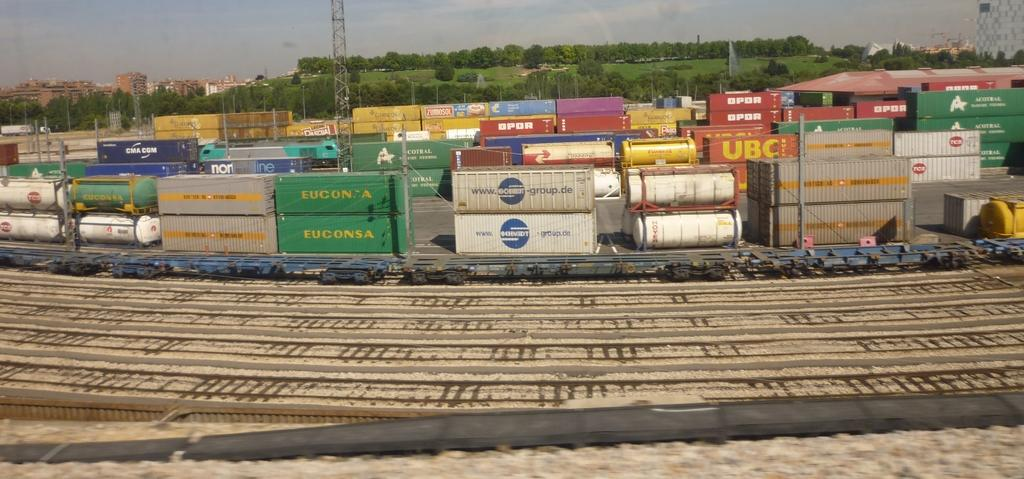<image>
Describe the image concisely. Railroad tracks show containers including a green Euconsa container. 